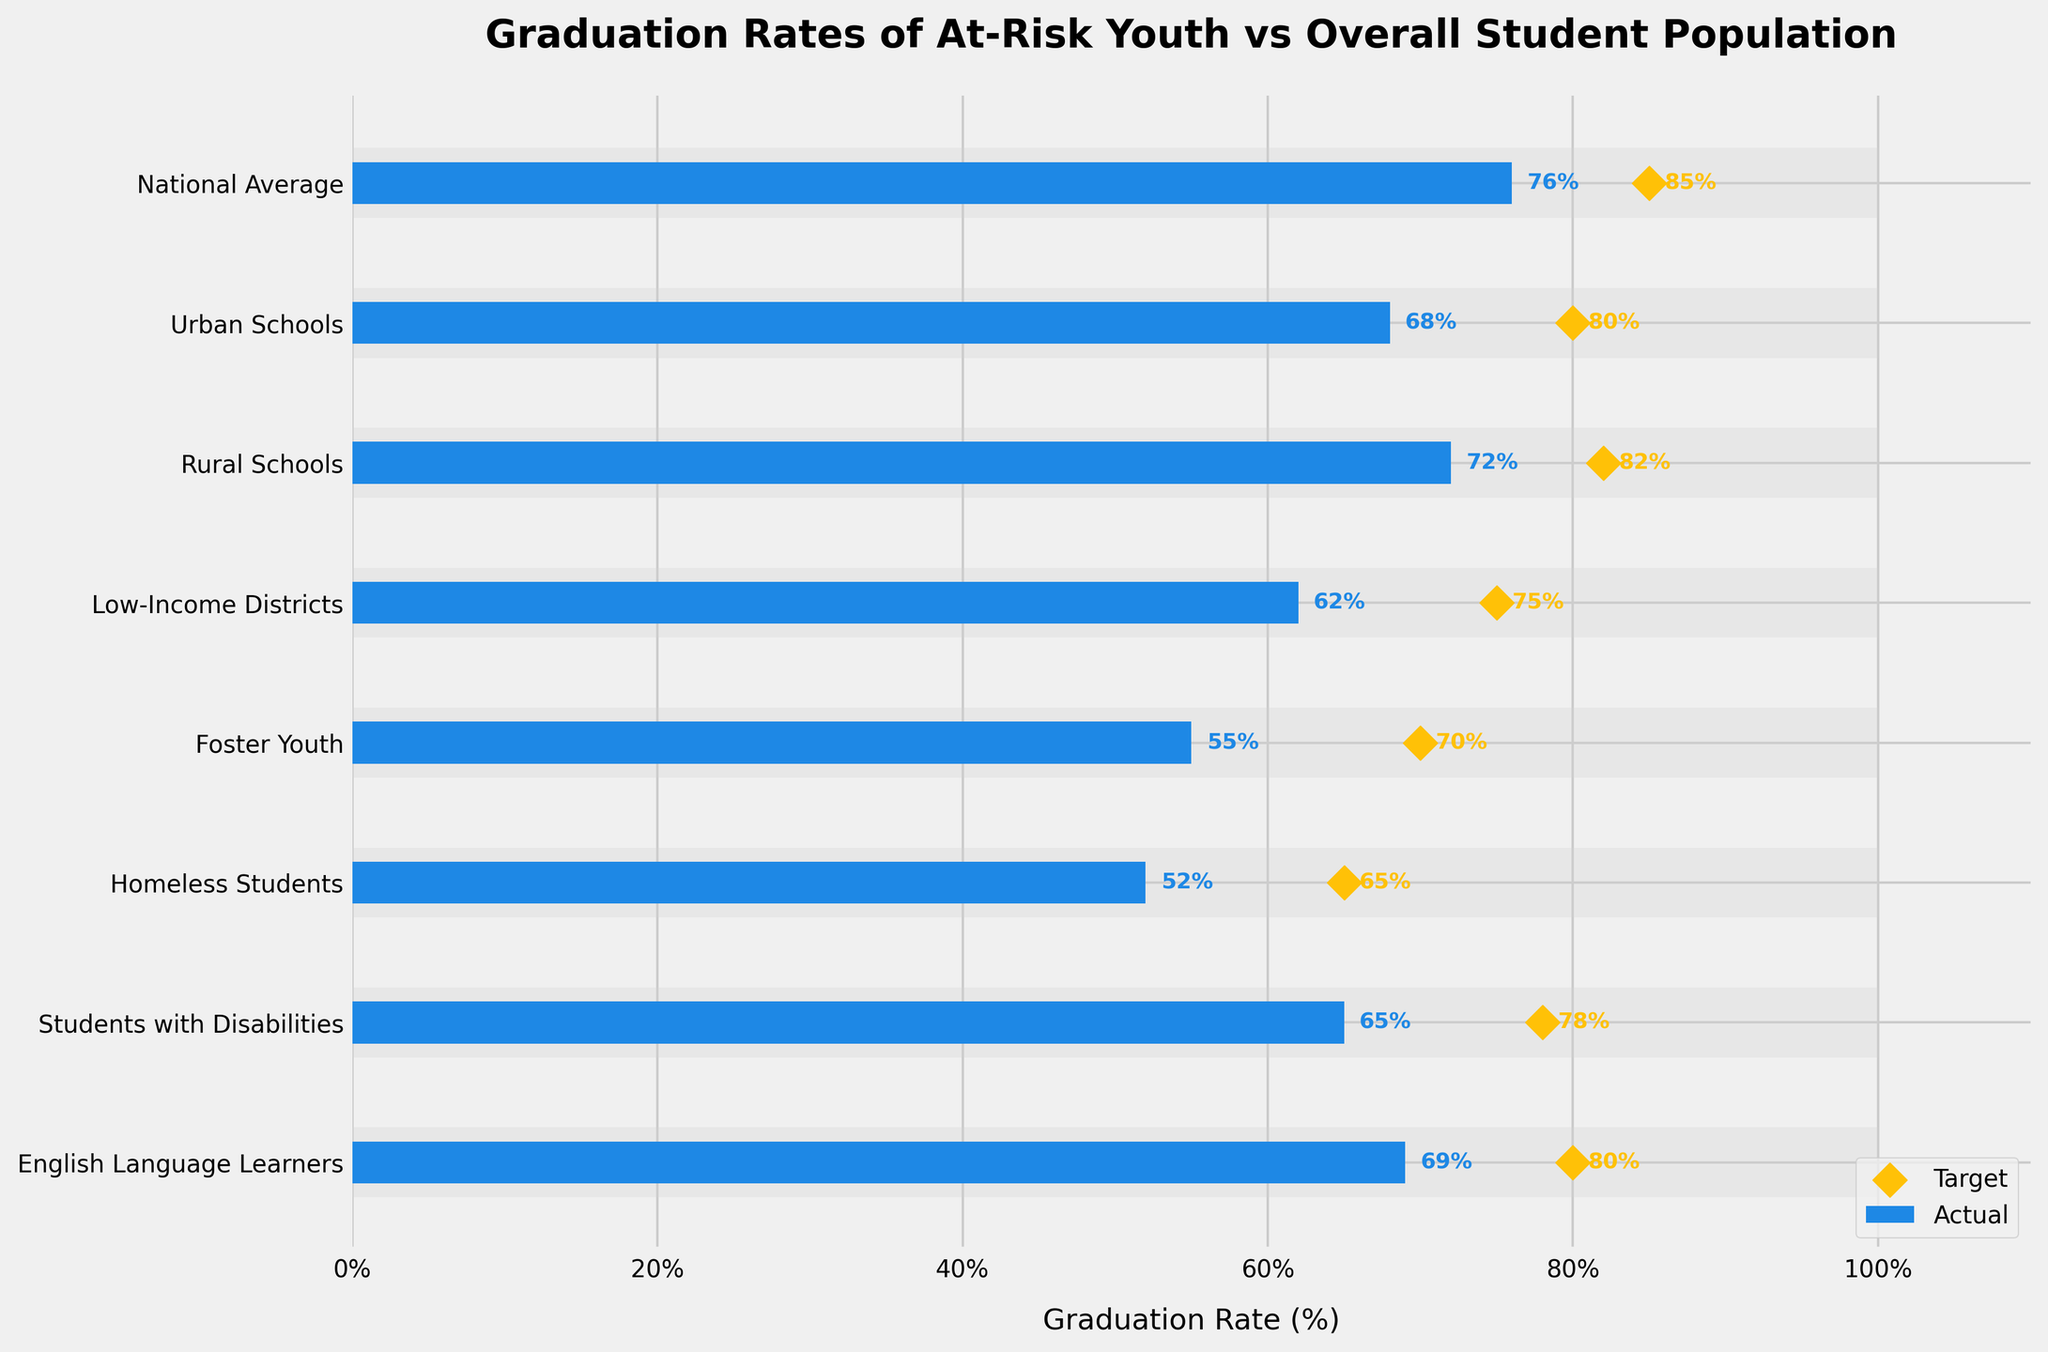How many categories are compared in the bullet chart? By counting the number of horizontal bars, each representing a category, we can determine the number of categories compared in the chart.
Answer: 8 Which category has the lowest actual graduation rate? All categories are listed on the y-axis along with their actual graduation rates displayed next to the bars. By finding the category with the smallest percentage, we identify the one with the lowest actual graduation rate.
Answer: Homeless Students What is the difference between the target graduation rate and the actual graduation rate for Low-Income Districts? From the bullet chart, the actual graduation rate for Low-Income Districts is 62%, and the target rate is 75%. Subtracting the actual rate from the target rate gives the difference: 75% - 62%.
Answer: 13% Which two categories have the same target graduation rate? We look at the target graduation rate markers (yellow diamonds) and their associated category labels. Upon checking, we find that Urban Schools and English Language Learners share the same target rate of 80%.
Answer: Urban Schools and English Language Learners What is the average actual graduation rate for Foster Youth, Homeless Students, and Students with Disabilities? To find the average, we first sum the actual graduation rates of the categories: Foster Youth (55%), Homeless Students (52%), and Students with Disabilities (65%). This results in 55 + 52 + 65 = 172. Dividing by the number of categories (3) gives the average: 172 / 3.
Answer: 57.33% Which category has the highest difference between the actual graduation rate and the national average comparative rate? Calculate the difference for each category from the comparative rate (100%) and find the highest: 
- National Average: 100% - 76% = 24%
- Urban Schools: 100% - 68% = 32%
- Rural Schools: 100% - 72% = 28%
- Low-Income Districts: 100% - 62% = 38%
- Foster Youth: 100% - 55% = 45%
- Homeless Students: 100% - 52% = 48%
- Students with Disabilities: 100% - 65% = 35%
- English Language Learners: 100% - 69% = 31% 
Homeless Students have the highest difference.
Answer: Homeless Students What is the total sum of all the actual graduation rates shown in the chart? To find the sum, add all the actual graduation rates:
76% (National Average) + 68% (Urban Schools) + 72% (Rural Schools) + 62% (Low-Income Districts) + 55% (Foster Youth) + 52% (Homeless Students) + 65% (Students with Disabilities) + 69% (English Language Learners) = 519%.
Answer: 519% Is the target graduation rate for Students with Disabilities higher than their actual graduation rate? By examining the actual rate (65%) and comparing it to the target rate (78%) for Students with Disabilities, we can see if the target is higher. Since 78% is greater than 65%, the target rate is higher.
Answer: Yes How many categories have an actual graduation rate higher than their target rate? Compare the actual and target rates for each category:
- National Average: 76% < 85%
- Urban Schools: 68% < 80%
- Rural Schools: 72% < 82%
- Low-Income Districts: 62% < 75%
- Foster Youth: 55% < 70%
- Homeless Students: 52% < 65%
- Students with Disabilities: 65% < 78%
- English Language Learners: 69% < 80%
None of the categories have an actual rate higher than their target rate, so the answer is zero.
Answer: 0 